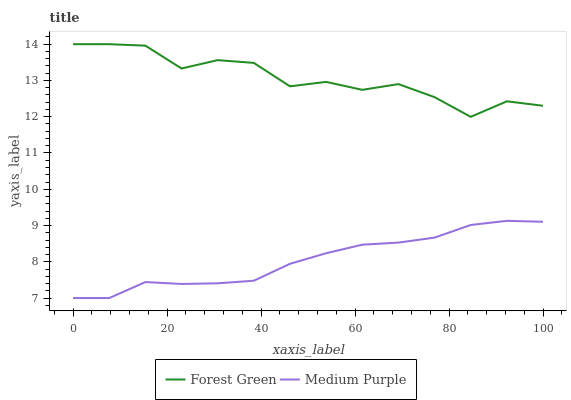Does Medium Purple have the minimum area under the curve?
Answer yes or no. Yes. Does Forest Green have the maximum area under the curve?
Answer yes or no. Yes. Does Forest Green have the minimum area under the curve?
Answer yes or no. No. Is Medium Purple the smoothest?
Answer yes or no. Yes. Is Forest Green the roughest?
Answer yes or no. Yes. Is Forest Green the smoothest?
Answer yes or no. No. Does Medium Purple have the lowest value?
Answer yes or no. Yes. Does Forest Green have the lowest value?
Answer yes or no. No. Does Forest Green have the highest value?
Answer yes or no. Yes. Is Medium Purple less than Forest Green?
Answer yes or no. Yes. Is Forest Green greater than Medium Purple?
Answer yes or no. Yes. Does Medium Purple intersect Forest Green?
Answer yes or no. No. 